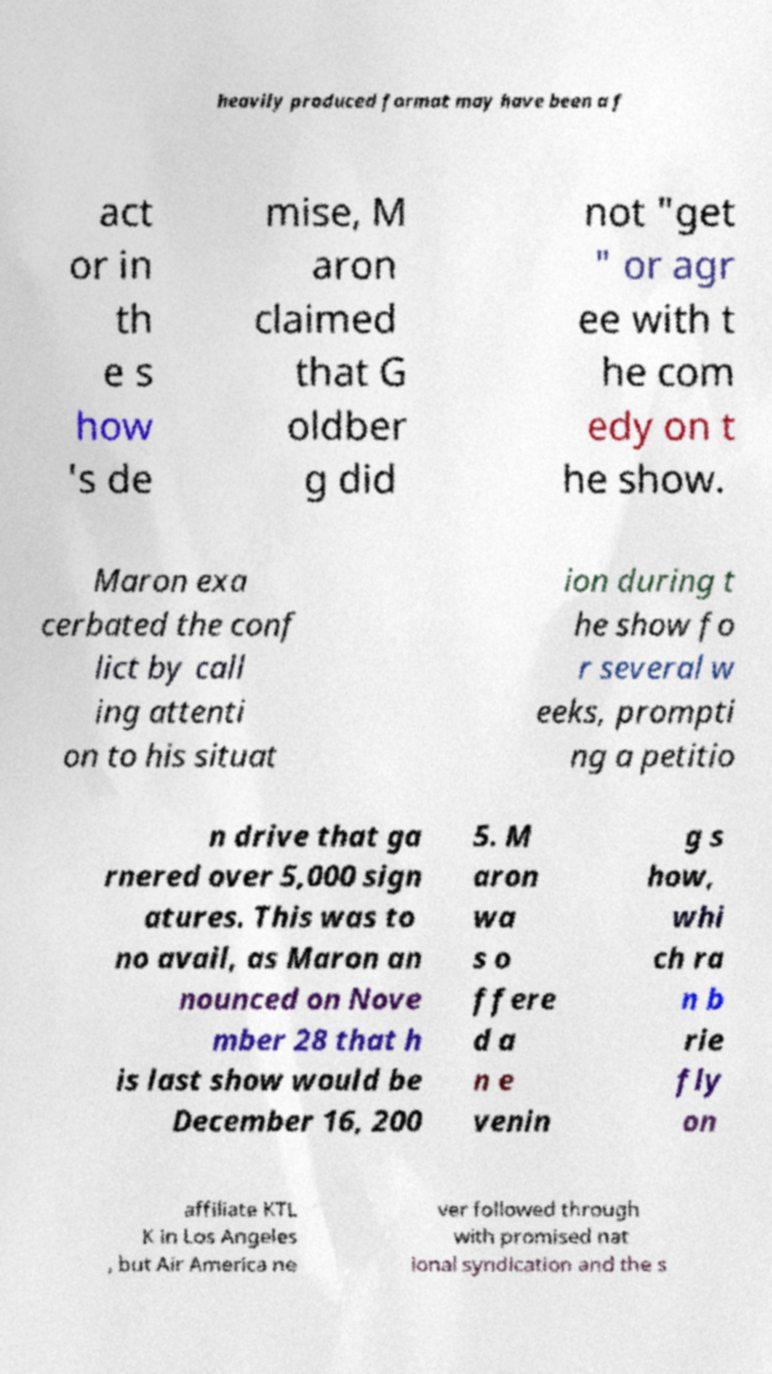Can you accurately transcribe the text from the provided image for me? heavily produced format may have been a f act or in th e s how 's de mise, M aron claimed that G oldber g did not "get " or agr ee with t he com edy on t he show. Maron exa cerbated the conf lict by call ing attenti on to his situat ion during t he show fo r several w eeks, prompti ng a petitio n drive that ga rnered over 5,000 sign atures. This was to no avail, as Maron an nounced on Nove mber 28 that h is last show would be December 16, 200 5. M aron wa s o ffere d a n e venin g s how, whi ch ra n b rie fly on affiliate KTL K in Los Angeles , but Air America ne ver followed through with promised nat ional syndication and the s 